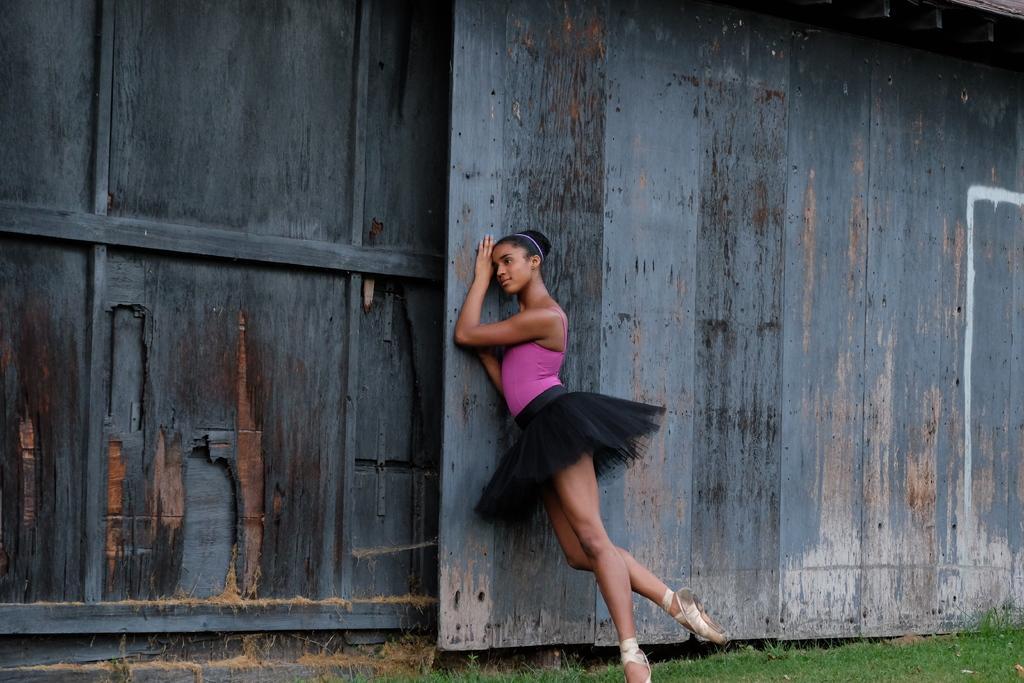Please provide a concise description of this image. In this image I can see a person standing. There are wooden walls and there is grass. 